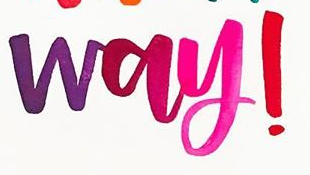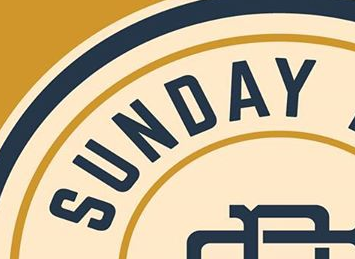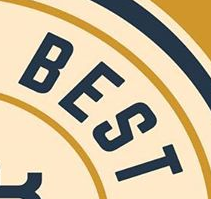Identify the words shown in these images in order, separated by a semicolon. way!; SUNDAY; BEST 